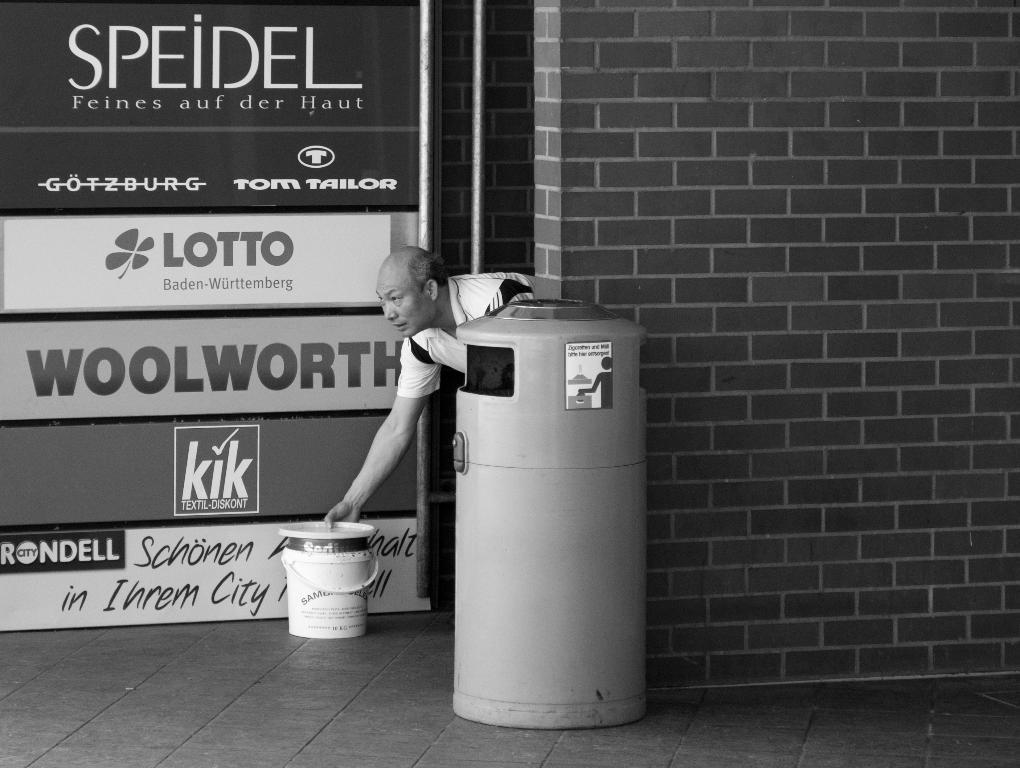<image>
Provide a brief description of the given image. The ad on the window is from Woolworth 